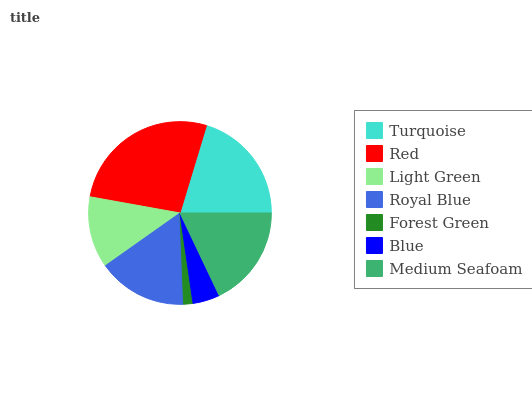Is Forest Green the minimum?
Answer yes or no. Yes. Is Red the maximum?
Answer yes or no. Yes. Is Light Green the minimum?
Answer yes or no. No. Is Light Green the maximum?
Answer yes or no. No. Is Red greater than Light Green?
Answer yes or no. Yes. Is Light Green less than Red?
Answer yes or no. Yes. Is Light Green greater than Red?
Answer yes or no. No. Is Red less than Light Green?
Answer yes or no. No. Is Royal Blue the high median?
Answer yes or no. Yes. Is Royal Blue the low median?
Answer yes or no. Yes. Is Blue the high median?
Answer yes or no. No. Is Turquoise the low median?
Answer yes or no. No. 